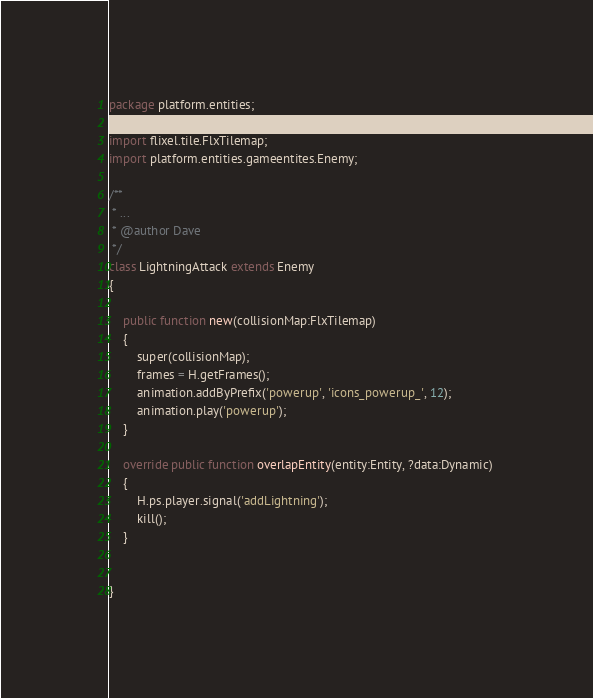<code> <loc_0><loc_0><loc_500><loc_500><_Haxe_>package platform.entities;

import flixel.tile.FlxTilemap;
import platform.entities.gameentites.Enemy;

/**
 * ...
 * @author Dave
 */
class LightningAttack extends Enemy 
{

	public function new(collisionMap:FlxTilemap) 
	{
		super(collisionMap);
		frames = H.getFrames();
		animation.addByPrefix('powerup', 'icons_powerup_', 12);
		animation.play('powerup');
	}
	
	override public function overlapEntity(entity:Entity, ?data:Dynamic) 
	{
		H.ps.player.signal('addLightning');
		kill();
	}
	
	
}</code> 